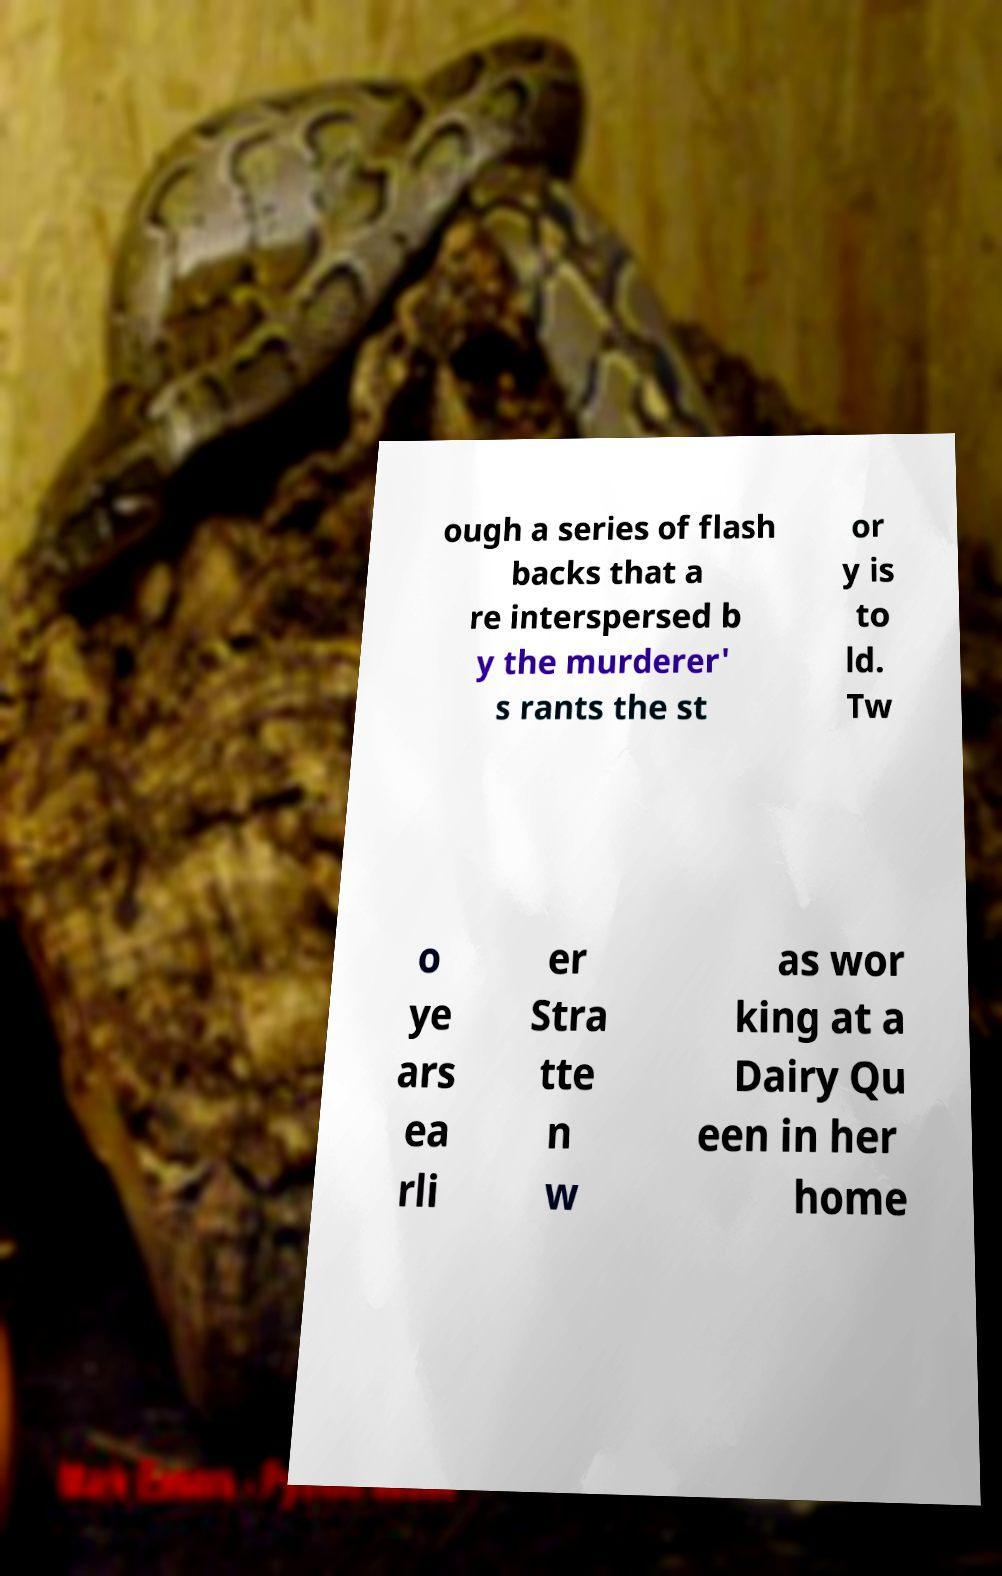Please identify and transcribe the text found in this image. ough a series of flash backs that a re interspersed b y the murderer' s rants the st or y is to ld. Tw o ye ars ea rli er Stra tte n w as wor king at a Dairy Qu een in her home 